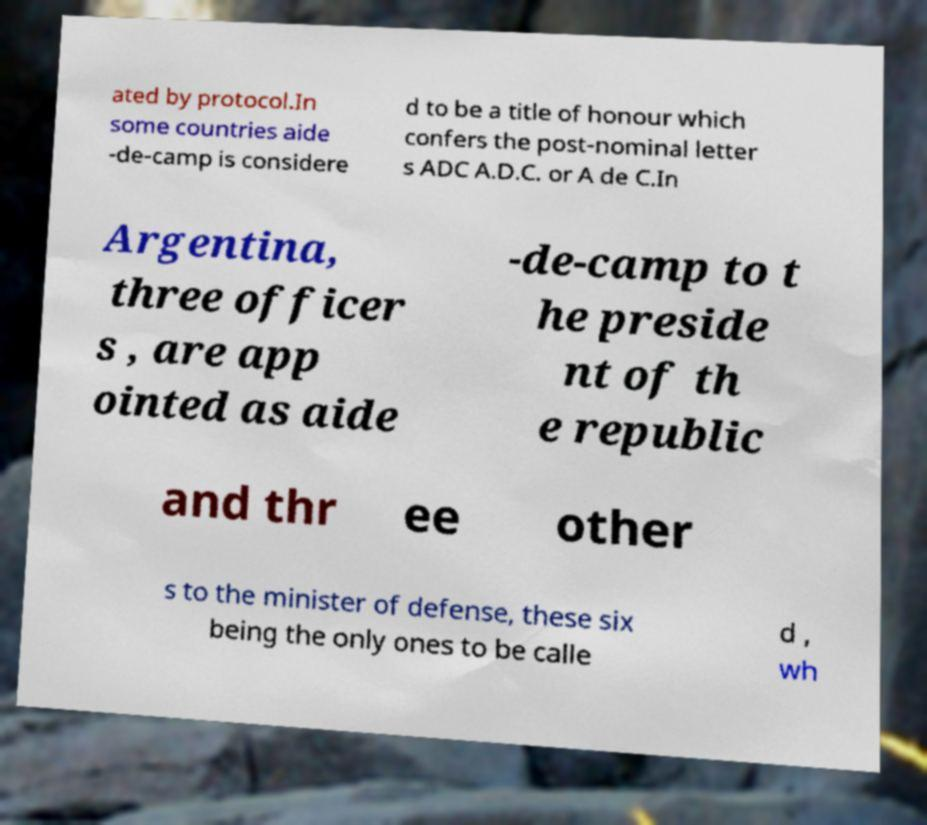There's text embedded in this image that I need extracted. Can you transcribe it verbatim? ated by protocol.In some countries aide -de-camp is considere d to be a title of honour which confers the post-nominal letter s ADC A.D.C. or A de C.In Argentina, three officer s , are app ointed as aide -de-camp to t he preside nt of th e republic and thr ee other s to the minister of defense, these six being the only ones to be calle d , wh 